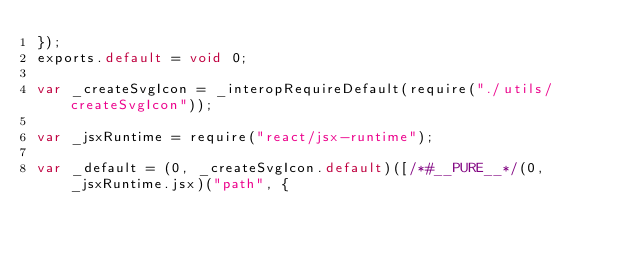<code> <loc_0><loc_0><loc_500><loc_500><_JavaScript_>});
exports.default = void 0;

var _createSvgIcon = _interopRequireDefault(require("./utils/createSvgIcon"));

var _jsxRuntime = require("react/jsx-runtime");

var _default = (0, _createSvgIcon.default)([/*#__PURE__*/(0, _jsxRuntime.jsx)("path", {</code> 